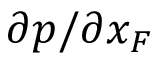Convert formula to latex. <formula><loc_0><loc_0><loc_500><loc_500>\partial p / \partial { x _ { F } }</formula> 